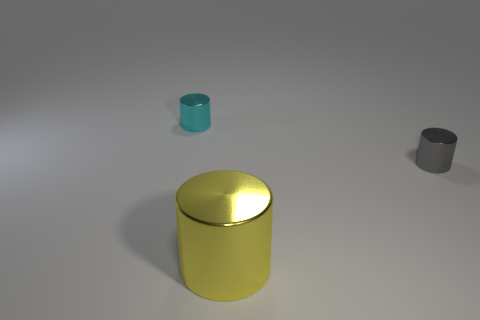Add 2 metal spheres. How many objects exist? 5 Add 1 big purple matte spheres. How many big purple matte spheres exist? 1 Subtract 0 brown cylinders. How many objects are left? 3 Subtract all big purple metallic blocks. Subtract all tiny cyan shiny cylinders. How many objects are left? 2 Add 2 metallic things. How many metallic things are left? 5 